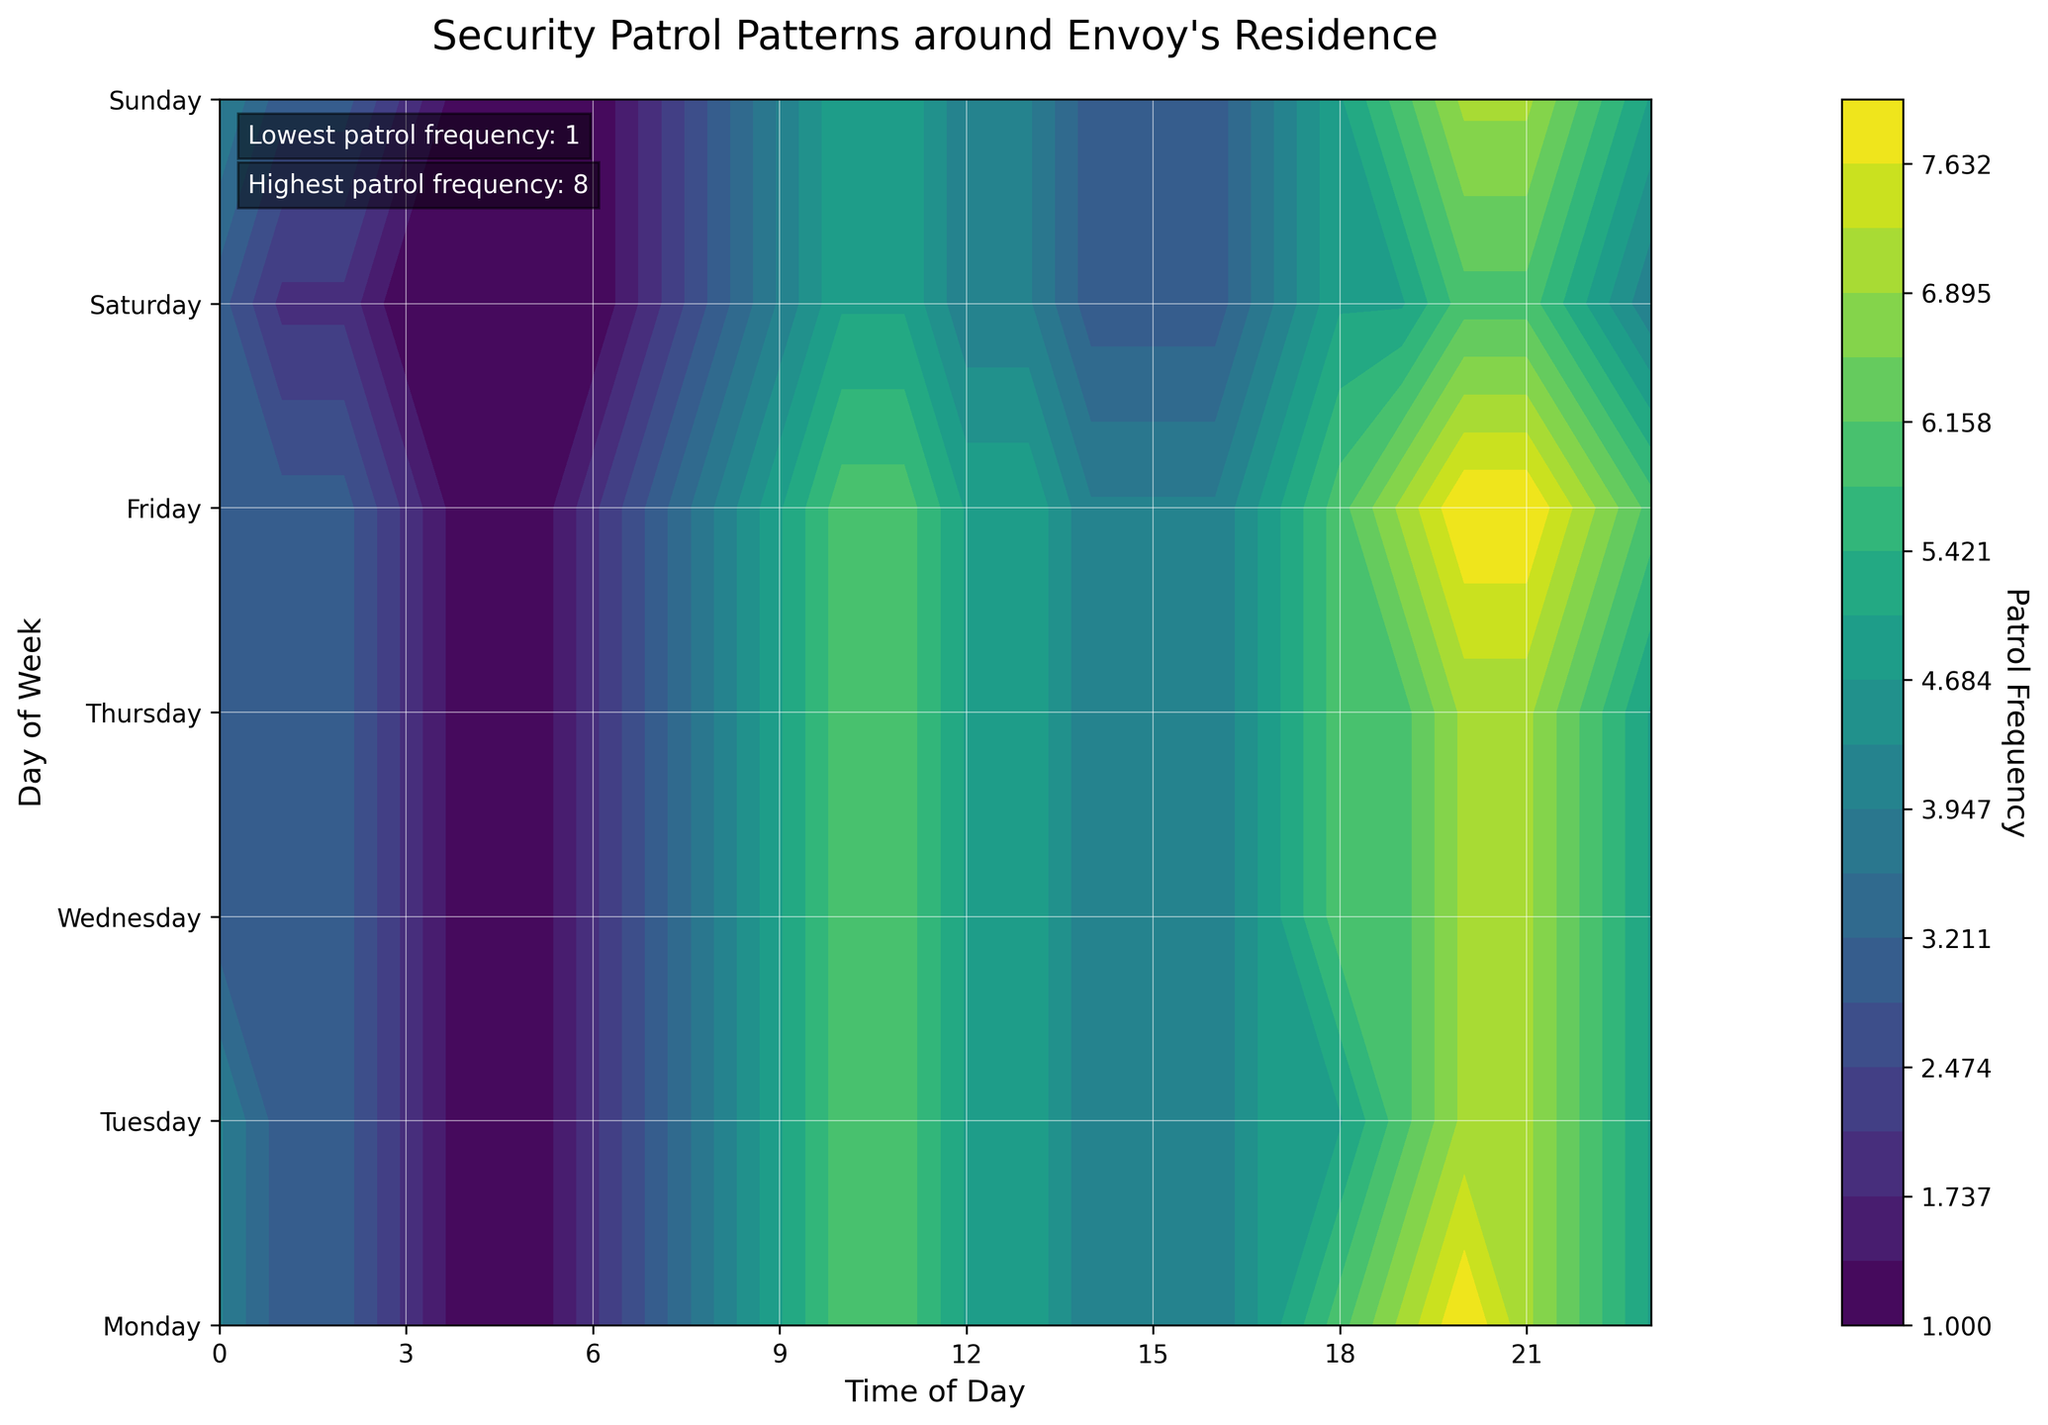What is the title of the figure? The title is usually placed at the top of the figure. Here, it clearly states the purpose of the visualization.
Answer: Security Patrol Patterns around Envoy's Residence Which day has the highest average patrol frequency? By visually inspecting the contour plot and noting the color intensity, it's evident that Monday and Friday have high-intensity regions more consistently throughout the day. Averaging the highest-intensity sections, Friday has the most noticeable high regions.
Answer: Friday At what time does the patrol frequency peak on Friday? Looking at the contour plot, the darkest color indicates the highest patrol frequency, which on Friday is darkest around 20:00 to 21:00.
Answer: 20:00–21:00 What is the minimum patrol frequency and when does it occur? The lightest color on the plot indicates the lowest frequency, which occurs at the early morning hours like 04:00 and similarly with 1 patrolling count.
Answer: 1 patrol (04:00) During which days do patrols tend to increase around evening (18:00) compared to the morning (06:00)? By comparing the intensity colors for 06:00 and 18:00 across the days, Monday, Wednesday, and Friday have noticeable increases in patrol frequency by evening.
Answer: Monday, Wednesday, Friday Which day shows a sudden rise in patrol frequency from early morning to noon? Observing the changes from morning to around 12:00, Monday typically shows a rapid increase compared to other days.
Answer: Monday How does the frequency pattern on Saturday compare to Sunday around 20:00? Comparing the color intensities for both days at 20:00, Saturday shows a lower frequency with lighter shading compared to the darker color seen on Sunday around the same time.
Answer: Sunday has higher frequency Which days have the most consistent patrol frequency throughout the day without large fluctuations? By observing the uniformity of color intensity from 00:00 to 23:00, Tuesday and Thursday appear more balanced with fewer drastic changes.
Answer: Tuesday, Thursday How many distinct patrol frequency levels are represented in the contour plot? The contour plot uses different color gradients to differentiate patrol frequencies. It is designed with 20 levels indicated by the color bar, showing gradated intervals.
Answer: 20 patrol levels 